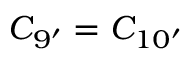<formula> <loc_0><loc_0><loc_500><loc_500>C _ { 9 ^ { \prime } } = C _ { 1 0 ^ { \prime } }</formula> 